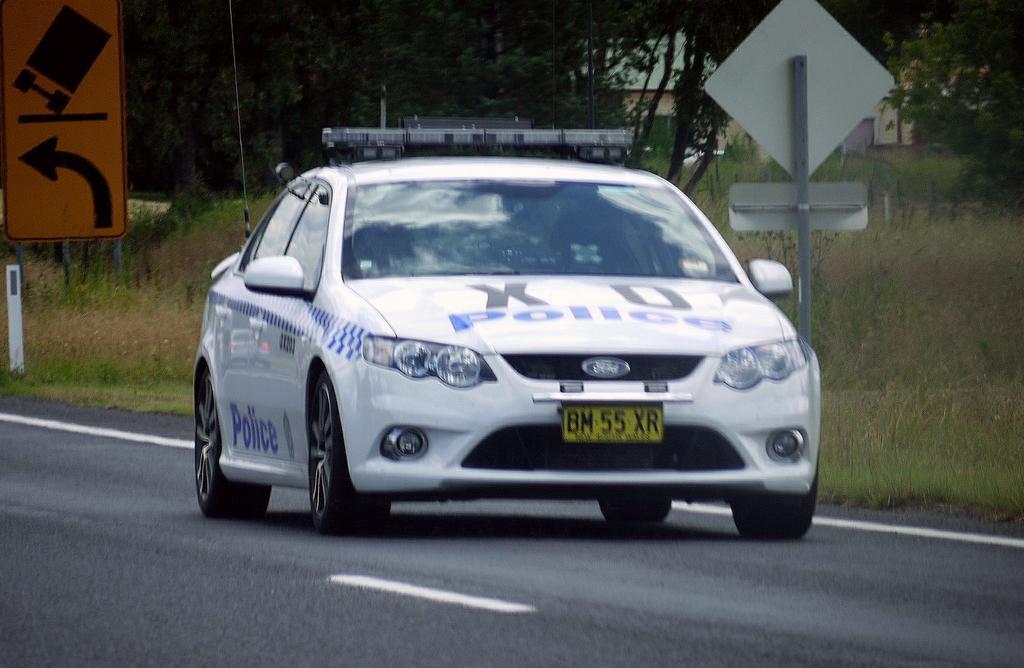Can you describe this image briefly? In this picture, we can see a vehicle, road, ground with grass, plants, trees, poles, sign boards, and we can see buildings. 